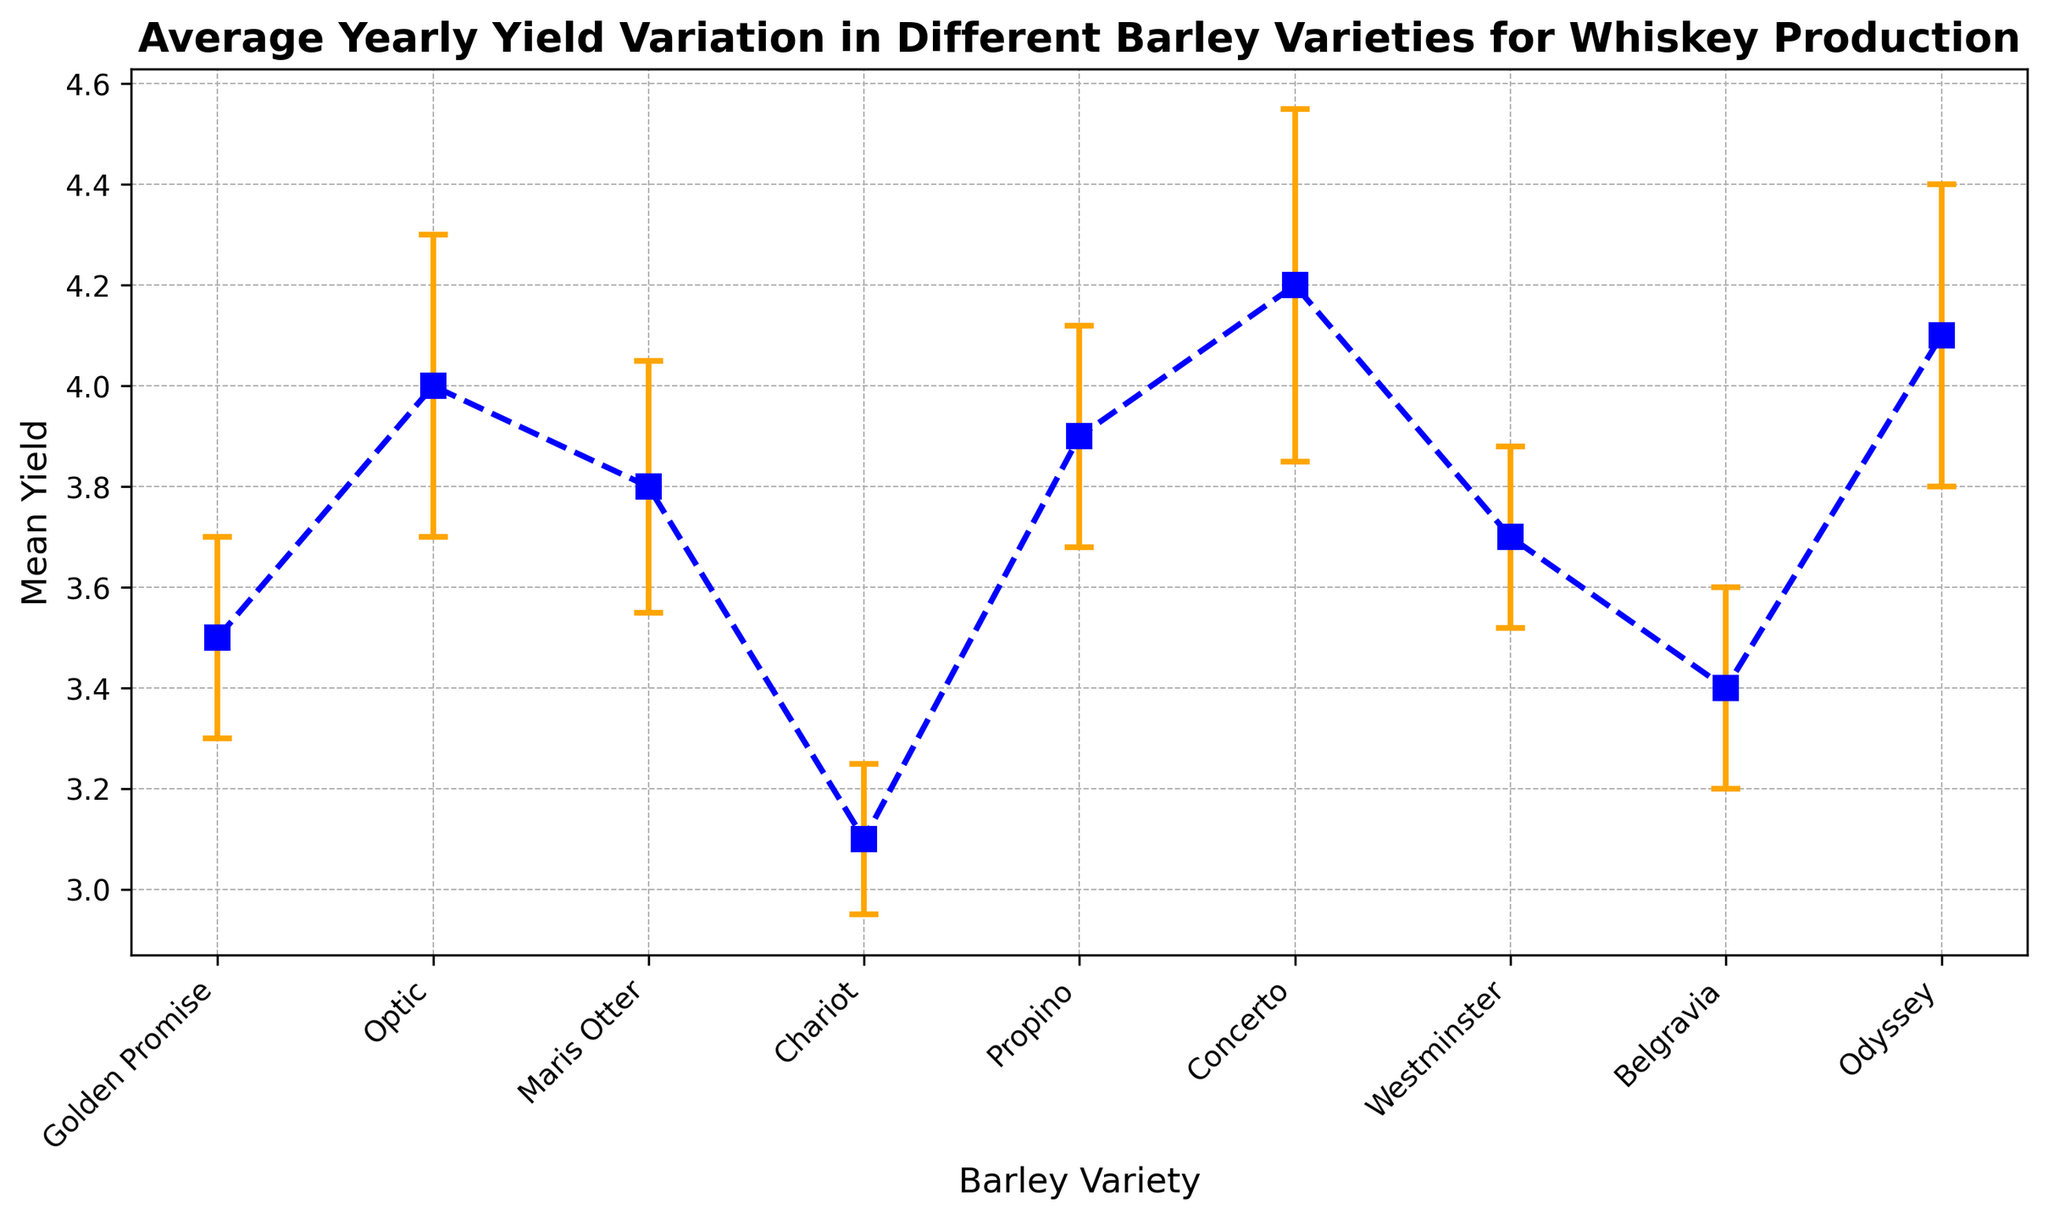Which barley variety has the highest mean yield? Looking at the mean yield values on the error bar chart, Concerto has the highest mean yield at 4.2.
Answer: Concerto Which barley variety shows the least variation in yield? Variation in yield is indicated by the length of the error bars. Chariot has the shortest error bars, indicating the least variation with a standard deviation of 0.15.
Answer: Chariot What is the difference in mean yield between Odyssey and Golden Promise? Odyssey has a mean yield of 4.1, and Golden Promise has a mean yield of 3.5. The difference is 4.1 - 3.5 = 0.6.
Answer: 0.6 Which barley varieties have a mean yield greater than 4? The barley varieties with mean yields greater than 4 are Optic, Concerto, and Odyssey.
Answer: Optic, Concerto, Odyssey What is the average mean yield of Propino, Maris Otter, and Belgravia? The mean yields are Propino (3.9), Maris Otter (3.8), and Belgravia (3.4). Their average yield is (3.9 + 3.8 + 3.4) / 3 = 3.7.
Answer: 3.7 Which barley variety has the second smallest mean yield? Chariot has the smallest mean yield at 3.1. The second smallest mean yield is from Belgravia at 3.4.
Answer: Belgravia What is the range of mean yields among all barley varieties? The highest mean yield is 4.2 (Concerto) and the lowest is 3.1 (Chariot). The range is 4.2 - 3.1 = 1.1.
Answer: 1.1 Compare the mean yield and variation of Optic and Maris Otter. Which has a higher yield and which has more variation? Optic has a mean yield of 4.0 and a standard deviation of 0.3, while Maris Otter has a mean yield of 3.8 and a standard deviation of 0.25. Optic has a higher mean yield, and more variation.
Answer: Optic has a higher yield and more variation Do Westminster and Propino have similar variations in yield? Westminster has a standard deviation of 0.18, and Propino has a standard deviation of 0.22. These are relatively close, indicating similar variations.
Answer: Yes Is there a visual trend in the yields among the different barley varieties? The yields vary, but there is a noticeable concentration of yields around 3.5 to 4.2, with a dispersion visible through the size of the error bars. The trend does not strongly favor any specific clustering.
Answer: Yields vary around 3.5 to 4.2 